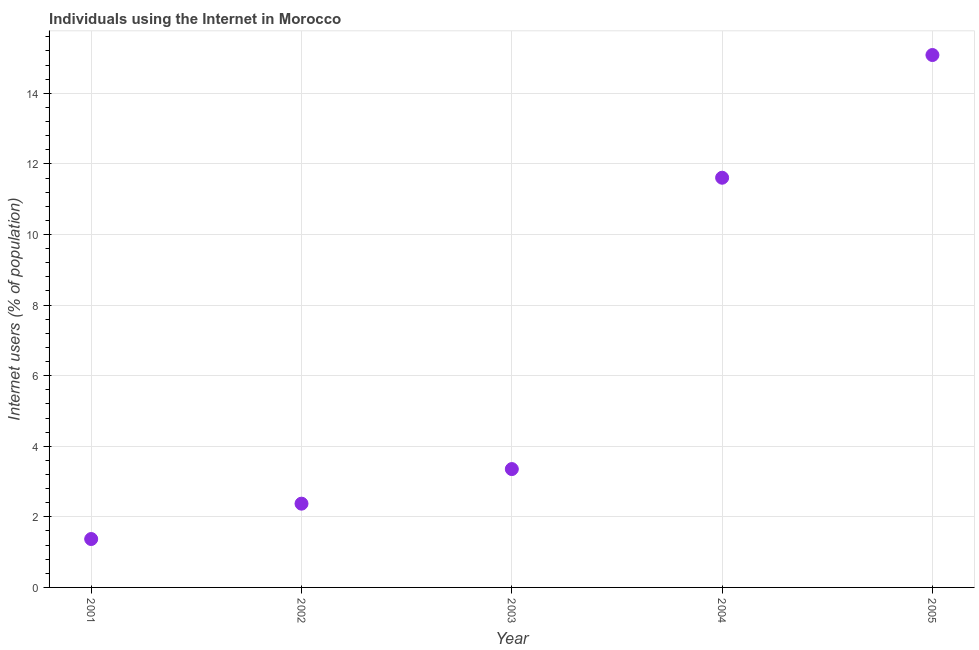What is the number of internet users in 2005?
Your answer should be compact. 15.08. Across all years, what is the maximum number of internet users?
Offer a terse response. 15.08. Across all years, what is the minimum number of internet users?
Your response must be concise. 1.37. In which year was the number of internet users maximum?
Ensure brevity in your answer.  2005. What is the sum of the number of internet users?
Provide a succinct answer. 33.79. What is the difference between the number of internet users in 2001 and 2002?
Keep it short and to the point. -1. What is the average number of internet users per year?
Ensure brevity in your answer.  6.76. What is the median number of internet users?
Make the answer very short. 3.35. What is the ratio of the number of internet users in 2004 to that in 2005?
Give a very brief answer. 0.77. What is the difference between the highest and the second highest number of internet users?
Provide a succinct answer. 3.48. What is the difference between the highest and the lowest number of internet users?
Your answer should be compact. 13.71. In how many years, is the number of internet users greater than the average number of internet users taken over all years?
Your answer should be very brief. 2. Does the number of internet users monotonically increase over the years?
Your answer should be compact. Yes. How many dotlines are there?
Give a very brief answer. 1. How many years are there in the graph?
Give a very brief answer. 5. What is the difference between two consecutive major ticks on the Y-axis?
Give a very brief answer. 2. Are the values on the major ticks of Y-axis written in scientific E-notation?
Your response must be concise. No. Does the graph contain any zero values?
Your response must be concise. No. Does the graph contain grids?
Ensure brevity in your answer.  Yes. What is the title of the graph?
Your answer should be very brief. Individuals using the Internet in Morocco. What is the label or title of the X-axis?
Offer a terse response. Year. What is the label or title of the Y-axis?
Provide a short and direct response. Internet users (% of population). What is the Internet users (% of population) in 2001?
Provide a short and direct response. 1.37. What is the Internet users (% of population) in 2002?
Your response must be concise. 2.37. What is the Internet users (% of population) in 2003?
Your answer should be very brief. 3.35. What is the Internet users (% of population) in 2004?
Your response must be concise. 11.61. What is the Internet users (% of population) in 2005?
Your answer should be very brief. 15.08. What is the difference between the Internet users (% of population) in 2001 and 2002?
Your answer should be compact. -1. What is the difference between the Internet users (% of population) in 2001 and 2003?
Make the answer very short. -1.98. What is the difference between the Internet users (% of population) in 2001 and 2004?
Make the answer very short. -10.24. What is the difference between the Internet users (% of population) in 2001 and 2005?
Provide a succinct answer. -13.71. What is the difference between the Internet users (% of population) in 2002 and 2003?
Offer a very short reply. -0.98. What is the difference between the Internet users (% of population) in 2002 and 2004?
Keep it short and to the point. -9.23. What is the difference between the Internet users (% of population) in 2002 and 2005?
Keep it short and to the point. -12.71. What is the difference between the Internet users (% of population) in 2003 and 2004?
Your answer should be compact. -8.25. What is the difference between the Internet users (% of population) in 2003 and 2005?
Give a very brief answer. -11.73. What is the difference between the Internet users (% of population) in 2004 and 2005?
Your answer should be compact. -3.48. What is the ratio of the Internet users (% of population) in 2001 to that in 2002?
Give a very brief answer. 0.58. What is the ratio of the Internet users (% of population) in 2001 to that in 2003?
Give a very brief answer. 0.41. What is the ratio of the Internet users (% of population) in 2001 to that in 2004?
Ensure brevity in your answer.  0.12. What is the ratio of the Internet users (% of population) in 2001 to that in 2005?
Ensure brevity in your answer.  0.09. What is the ratio of the Internet users (% of population) in 2002 to that in 2003?
Your response must be concise. 0.71. What is the ratio of the Internet users (% of population) in 2002 to that in 2004?
Give a very brief answer. 0.2. What is the ratio of the Internet users (% of population) in 2002 to that in 2005?
Your answer should be compact. 0.16. What is the ratio of the Internet users (% of population) in 2003 to that in 2004?
Ensure brevity in your answer.  0.29. What is the ratio of the Internet users (% of population) in 2003 to that in 2005?
Your response must be concise. 0.22. What is the ratio of the Internet users (% of population) in 2004 to that in 2005?
Provide a succinct answer. 0.77. 